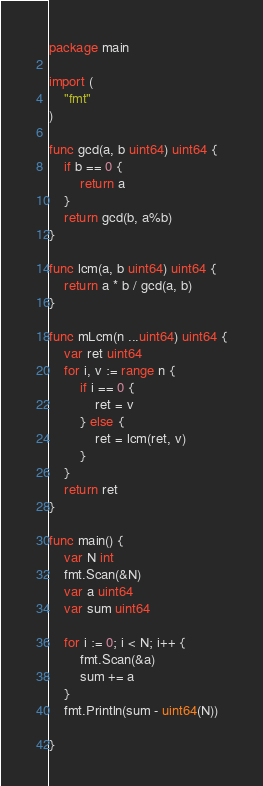<code> <loc_0><loc_0><loc_500><loc_500><_Go_>package main

import (
	"fmt"
)

func gcd(a, b uint64) uint64 {
	if b == 0 {
		return a
	}
	return gcd(b, a%b)
}

func lcm(a, b uint64) uint64 {
	return a * b / gcd(a, b)
}

func mLcm(n ...uint64) uint64 {
	var ret uint64
	for i, v := range n {
		if i == 0 {
			ret = v
		} else {
			ret = lcm(ret, v)
		}
	}
	return ret
}

func main() {
	var N int
	fmt.Scan(&N)
	var a uint64
	var sum uint64

	for i := 0; i < N; i++ {
		fmt.Scan(&a)
		sum += a
	}
	fmt.Println(sum - uint64(N))

}
</code> 